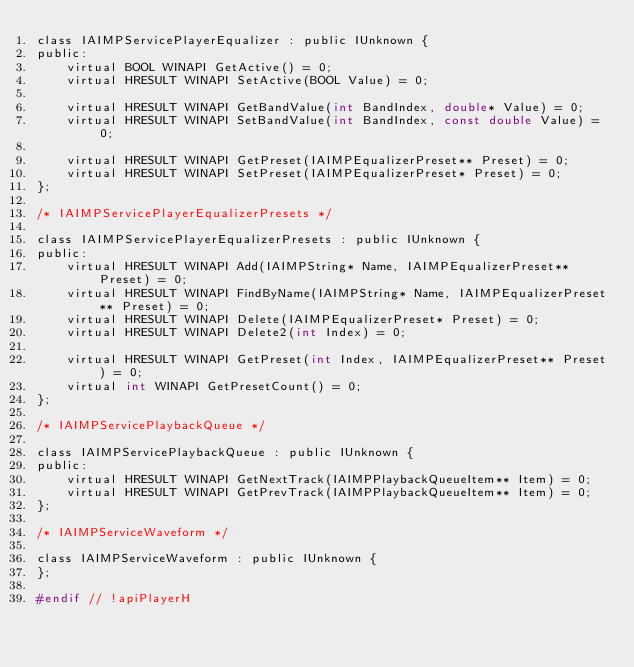<code> <loc_0><loc_0><loc_500><loc_500><_C_>class IAIMPServicePlayerEqualizer : public IUnknown {
public:
    virtual BOOL WINAPI GetActive() = 0;
    virtual HRESULT WINAPI SetActive(BOOL Value) = 0;

    virtual HRESULT WINAPI GetBandValue(int BandIndex, double* Value) = 0;
    virtual HRESULT WINAPI SetBandValue(int BandIndex, const double Value) = 0;

    virtual HRESULT WINAPI GetPreset(IAIMPEqualizerPreset** Preset) = 0;
    virtual HRESULT WINAPI SetPreset(IAIMPEqualizerPreset* Preset) = 0;
};

/* IAIMPServicePlayerEqualizerPresets */

class IAIMPServicePlayerEqualizerPresets : public IUnknown {
public:
    virtual HRESULT WINAPI Add(IAIMPString* Name, IAIMPEqualizerPreset** Preset) = 0;
    virtual HRESULT WINAPI FindByName(IAIMPString* Name, IAIMPEqualizerPreset** Preset) = 0;
    virtual HRESULT WINAPI Delete(IAIMPEqualizerPreset* Preset) = 0;
    virtual HRESULT WINAPI Delete2(int Index) = 0;

    virtual HRESULT WINAPI GetPreset(int Index, IAIMPEqualizerPreset** Preset) = 0;
    virtual int WINAPI GetPresetCount() = 0;
};

/* IAIMPServicePlaybackQueue */

class IAIMPServicePlaybackQueue : public IUnknown {
public:
    virtual HRESULT WINAPI GetNextTrack(IAIMPPlaybackQueueItem** Item) = 0;
    virtual HRESULT WINAPI GetPrevTrack(IAIMPPlaybackQueueItem** Item) = 0;
};

/* IAIMPServiceWaveform */

class IAIMPServiceWaveform : public IUnknown {
};

#endif // !apiPlayerH
</code> 